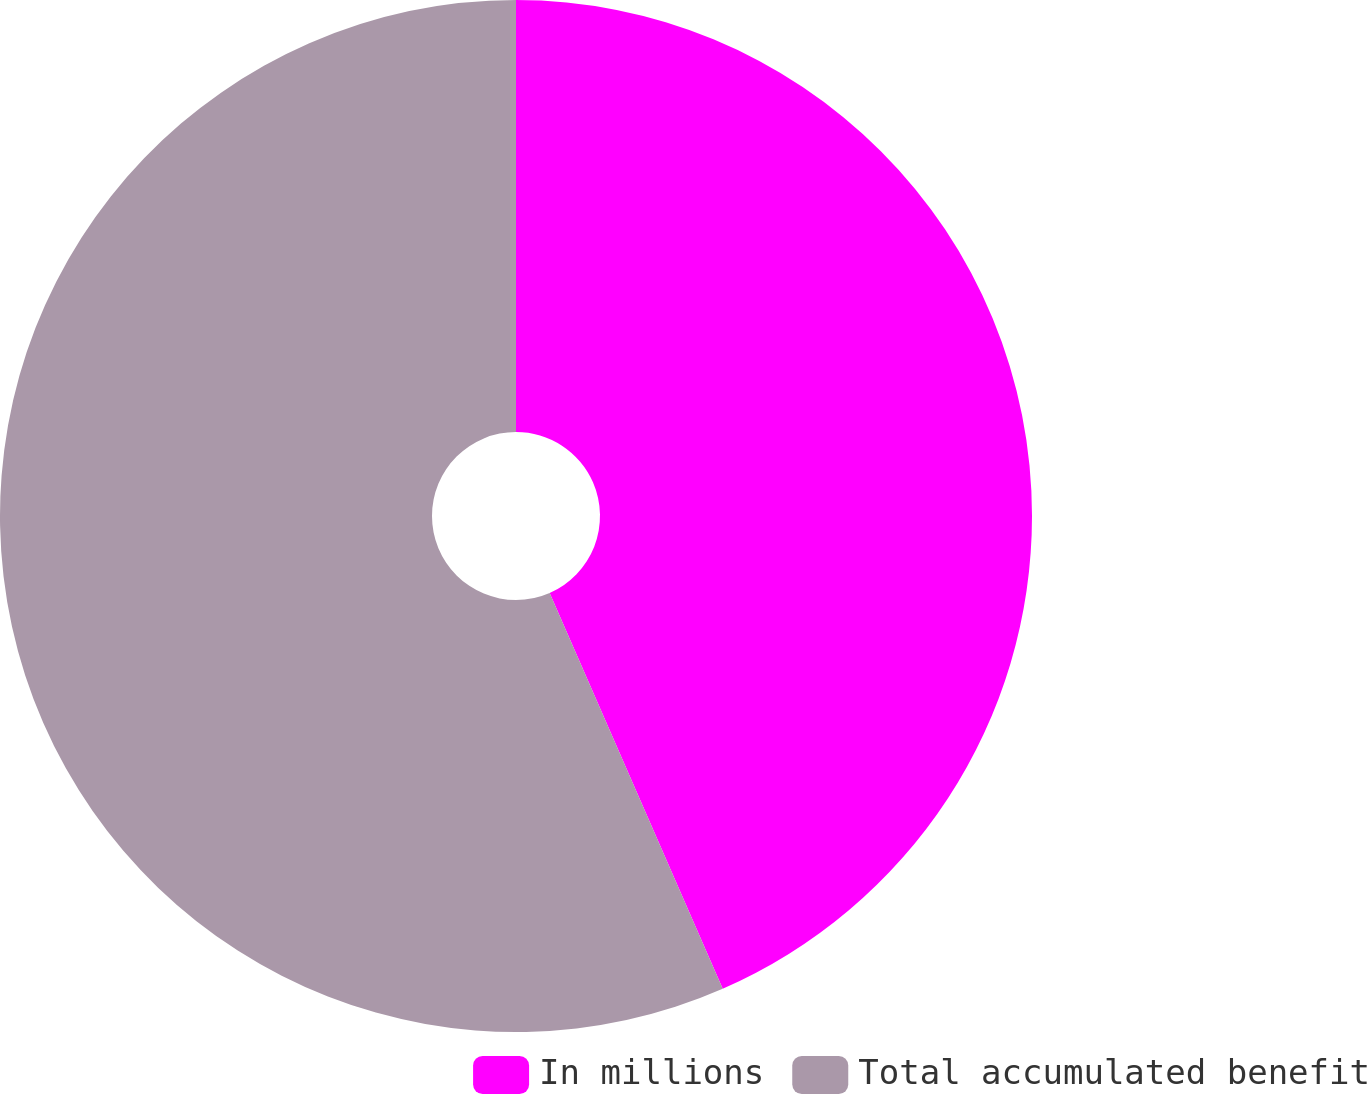Convert chart. <chart><loc_0><loc_0><loc_500><loc_500><pie_chart><fcel>In millions<fcel>Total accumulated benefit<nl><fcel>43.44%<fcel>56.56%<nl></chart> 